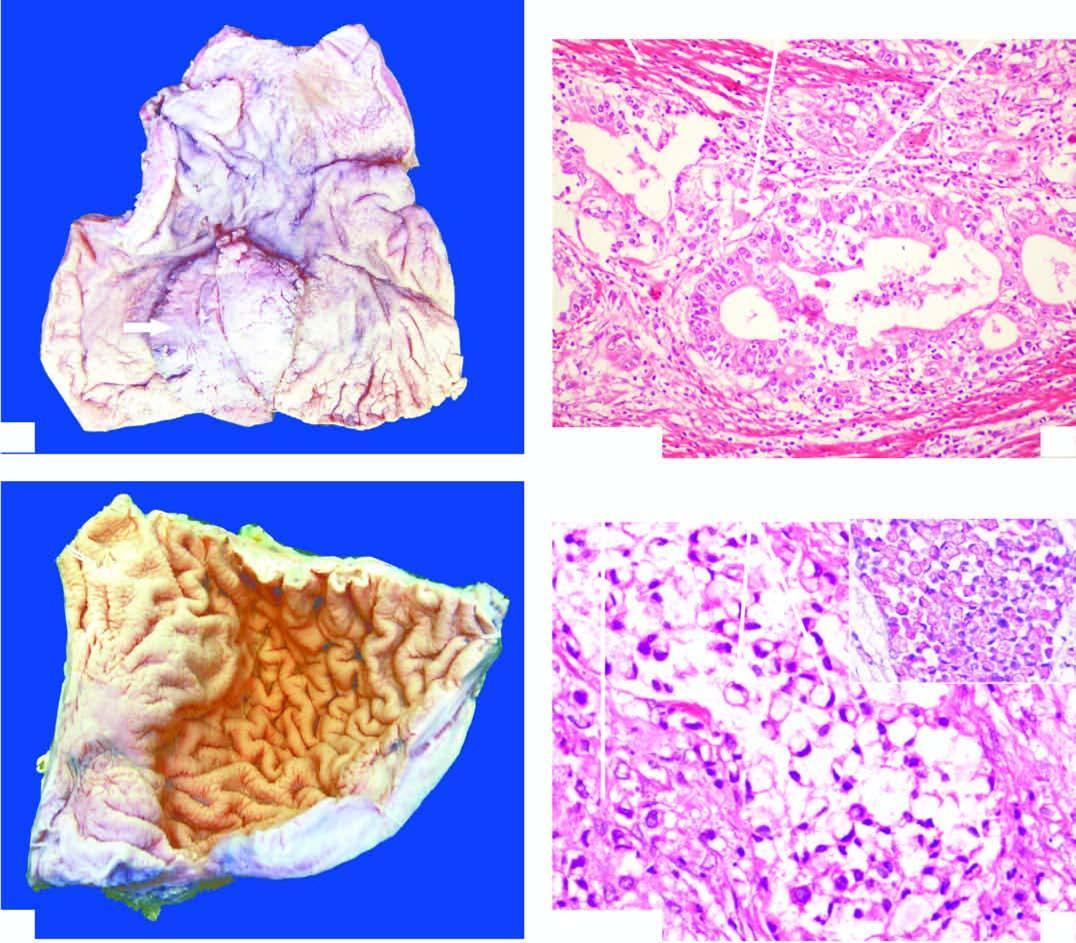what is markedly thickened?
Answer the question using a single word or phrase. Wall of the stomach in the region of pyloric canal 